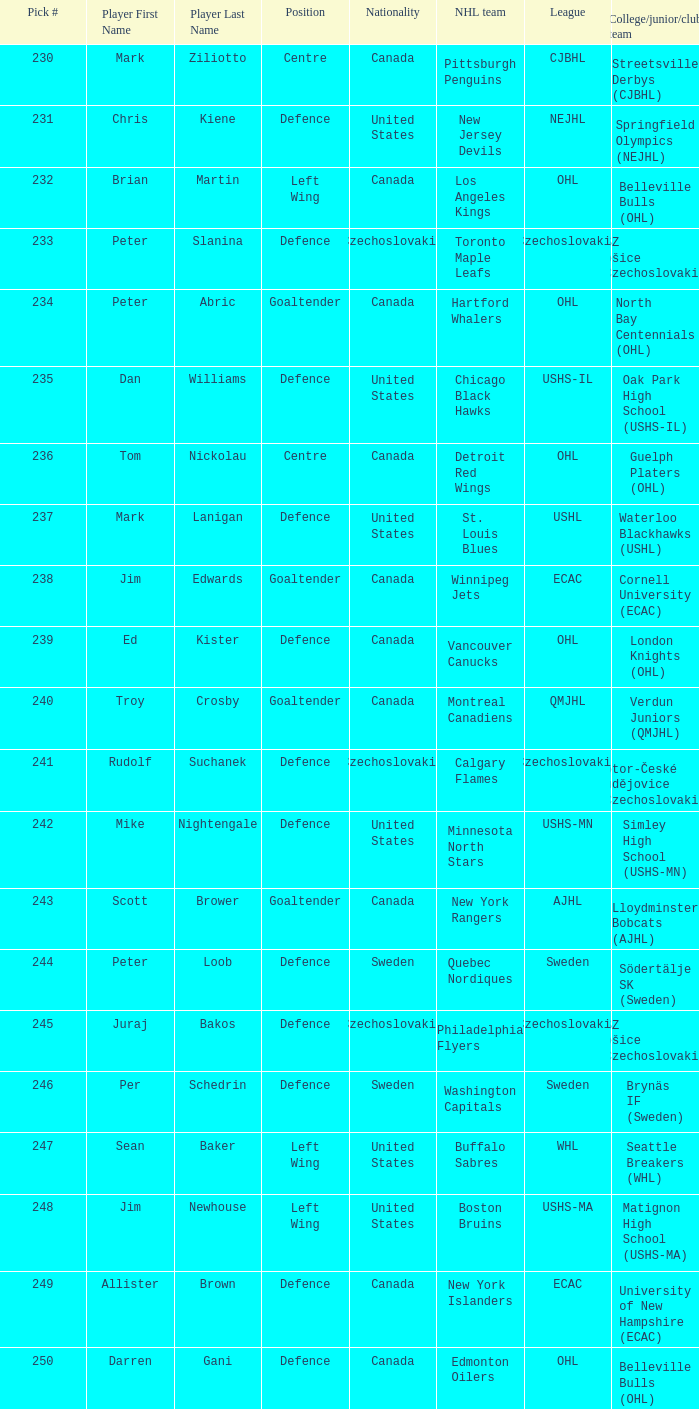To which institution does the winnipeg jets belong to? Cornell University (ECAC). 